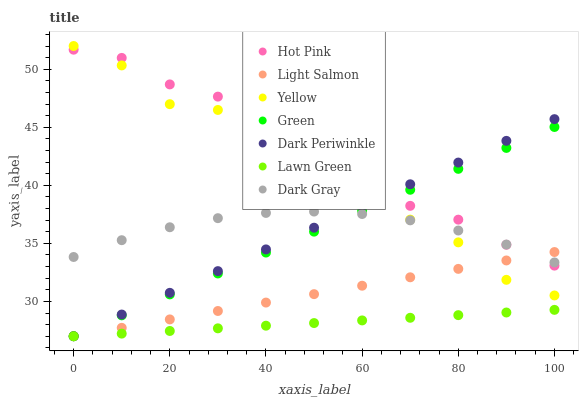Does Lawn Green have the minimum area under the curve?
Answer yes or no. Yes. Does Hot Pink have the maximum area under the curve?
Answer yes or no. Yes. Does Light Salmon have the minimum area under the curve?
Answer yes or no. No. Does Light Salmon have the maximum area under the curve?
Answer yes or no. No. Is Lawn Green the smoothest?
Answer yes or no. Yes. Is Yellow the roughest?
Answer yes or no. Yes. Is Light Salmon the smoothest?
Answer yes or no. No. Is Light Salmon the roughest?
Answer yes or no. No. Does Lawn Green have the lowest value?
Answer yes or no. Yes. Does Hot Pink have the lowest value?
Answer yes or no. No. Does Yellow have the highest value?
Answer yes or no. Yes. Does Light Salmon have the highest value?
Answer yes or no. No. Is Lawn Green less than Dark Gray?
Answer yes or no. Yes. Is Yellow greater than Lawn Green?
Answer yes or no. Yes. Does Dark Gray intersect Yellow?
Answer yes or no. Yes. Is Dark Gray less than Yellow?
Answer yes or no. No. Is Dark Gray greater than Yellow?
Answer yes or no. No. Does Lawn Green intersect Dark Gray?
Answer yes or no. No. 